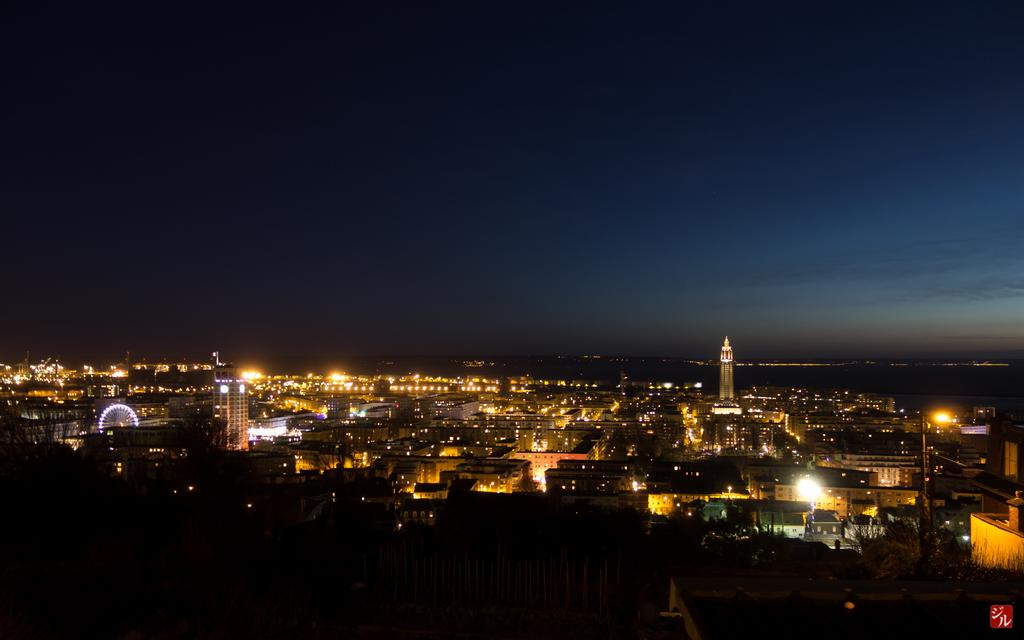What type of structures can be seen in the image? There are buildings in the image. What can be observed illuminating the scene in the image? There are lights visible in the image. What type of dress is the maid wearing in the image? There is no maid or dress present in the image. 